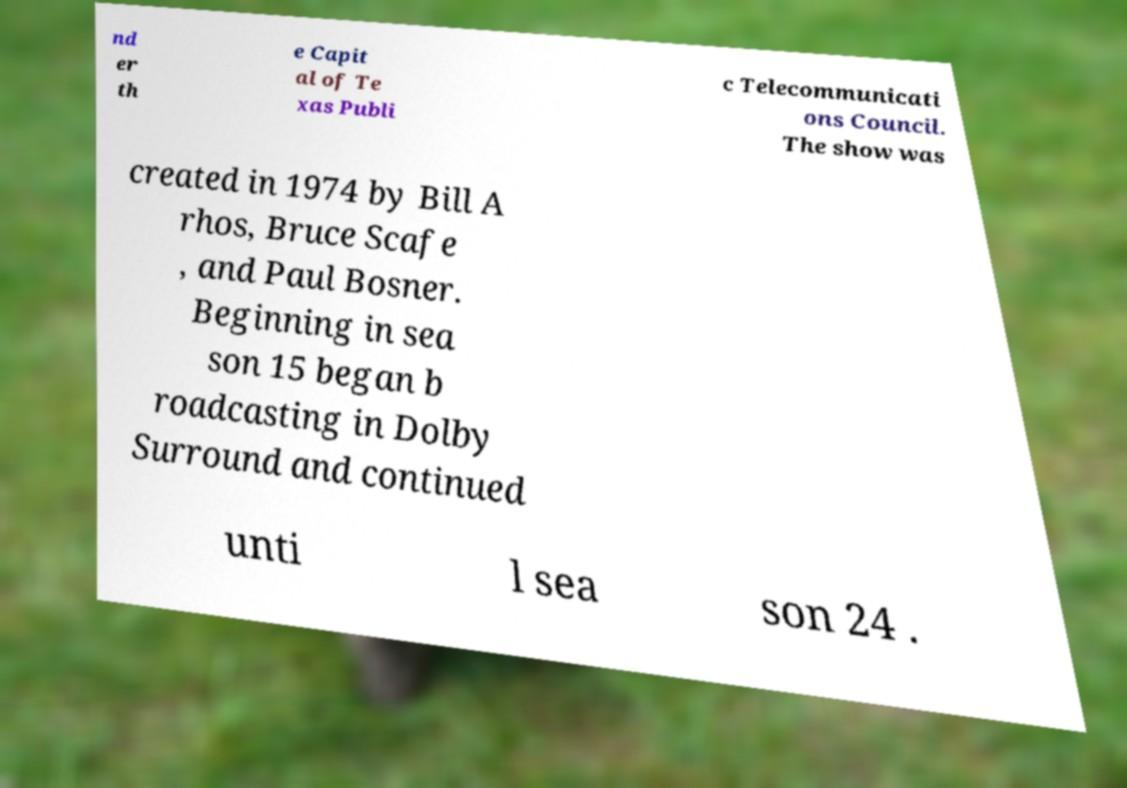Can you read and provide the text displayed in the image?This photo seems to have some interesting text. Can you extract and type it out for me? nd er th e Capit al of Te xas Publi c Telecommunicati ons Council. The show was created in 1974 by Bill A rhos, Bruce Scafe , and Paul Bosner. Beginning in sea son 15 began b roadcasting in Dolby Surround and continued unti l sea son 24 . 